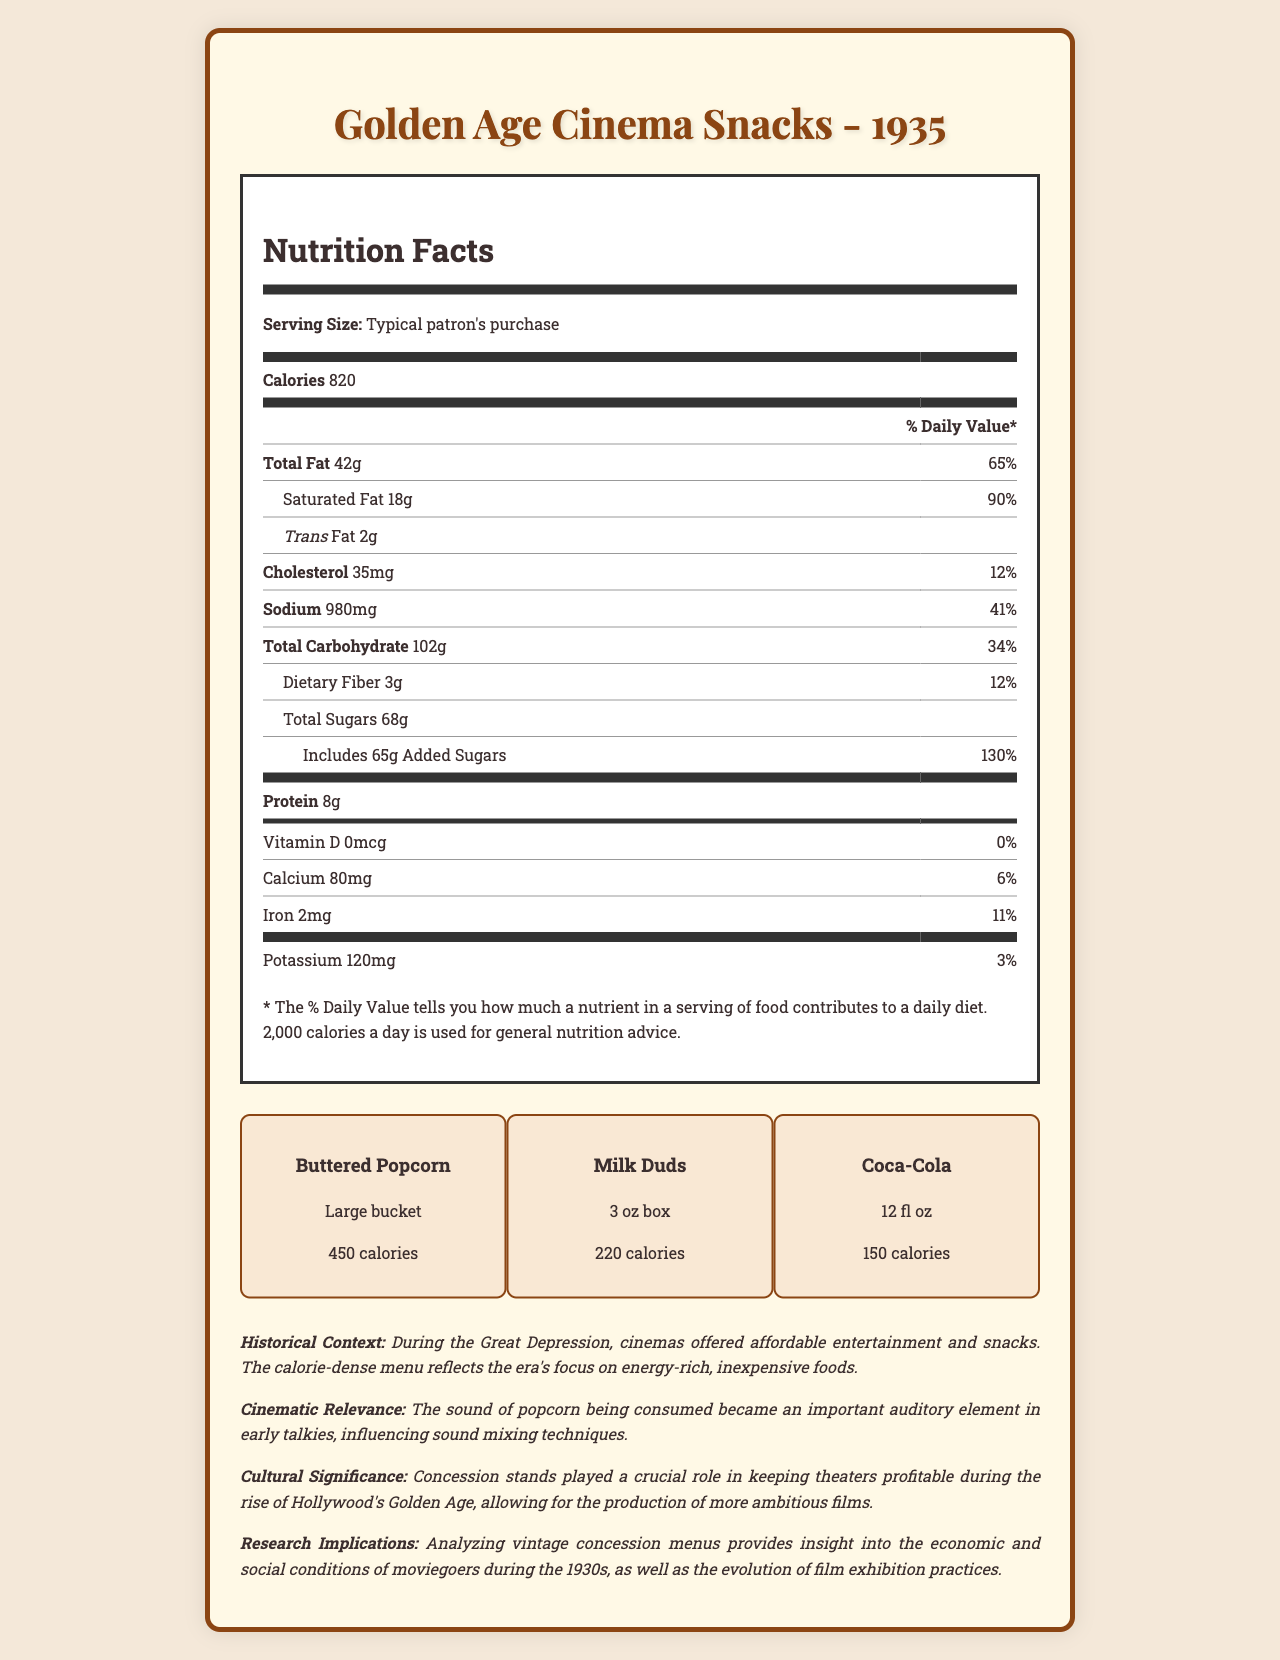what is the total calorie count for a typical patron's purchase? The document mentions that the calories per serving for a typical patron's purchase is 820.
Answer: 820 how many grams of total fat are present in the menu item? The document specifies that there are 42 grams of total fat in the serving size of a typical patron's purchase.
Answer: 42 grams what is the historical context mentioned in the document? The historical context is described in the document's context section.
Answer: During the Great Depression, cinemas offered affordable entertainment and snacks. The calorie-dense menu reflects the era's focus on energy-rich, inexpensive foods. which of the following menu items contains the highest number of calories? A. Buttered Popcorn B. Milk Duds C. Coca-Cola Buttered Popcorn has 450 calories, which is higher than Milk Duds (220 calories) and Coca-Cola (150 calories).
Answer: Buttered Popcorn what is the percentage of daily value for sodium in a typical patron's purchase? The sodium content is 980 mg, and this is 41% of the daily value for sodium.
Answer: 41% which item contributed the highest number of calories to the menu? Buttered Popcorn contributes the highest number of calories at 450.
Answer: Buttered Popcorn how many grams of added sugars are included in the purchase? The document indicates that there are 65 grams of added sugars in the typical patron's purchase.
Answer: 65 grams what is the cinematic relevance of the menu described in the document? The document's context section mentions this cinematic relevance.
Answer: The sound of popcorn being consumed became an important auditory element in early talkies, influencing sound mixing techniques. does the document mention the presence of any vitamins? The document mentions Vitamin D with a value of 0 mcg.
Answer: Yes summarize the document about Golden Age Cinema Snacks' menu from 1935. The summary captures the main points including nutritional details, menu items, historical and cultural context, cinematic relevance, and research implications.
Answer: The Golden Age Cinema Snacks menu from 1935 includes a nutrition facts label detailing the calorie and nutritional breakdown for a typical patron's purchase, which totals 820 calories. The menu items include Buttered Popcorn, Milk Duds, and Coca-Cola. The historical context indicates that during the Great Depression, cinemas provided energy-rich, inexpensive foods. Cinematic relevance is noted in the sound of popcorn enhancing early movies, and cultural significance highlights the economic importance of concession stands in cinema profitability. The research implications suggest insights into 1930s moviegoer lifestyles and the evolution of film exhibition. what is the total carbohydrate content of a typical patron's purchase? The document lists total carbohydrates as 102 grams in the nutrition facts section.
Answer: 102 grams what is the daily value percentage for saturated fat? A. 25% B. 75% C. 90% The document states that a typical purchase contains 18 grams of saturated fat, which equates to 90% of the daily value.
Answer: 90% what is the size of the Milk Duds item on the menu? The document specifies that the Milk Duds item is a 3 oz box.
Answer: 3 oz box how much protein is in a typical patron's purchase? The nutrition facts state that there are 8 grams of protein in a typical patron's purchase.
Answer: 8 grams is there any iron present in the typical purchase? The document shows that there are 2 mg of iron, which is 11% of the daily value.
Answer: Yes how did the calorie-dense menu items reflect the economic conditions of the 1930s? This information can be found in the historical context section.
Answer: The calorie-dense menu reflects the era's focus on energy-rich, inexpensive foods due to the Great Depression. what role did concession stands play during Hollywood's Golden Age? The cultural significance section of the document provides this information.
Answer: Concession stands played a crucial role in keeping theaters profitable during the rise of Hollywood's Golden Age, allowing for the production of more ambitious films. what's the total added sugar percentage of the daily value in the purchase? The document states that 65 grams of added sugars equals 130% of the daily value.
Answer: 130% what is the sodium content of Buttered Popcorn? The document provides the sodium content for a typical purchase but does not break it down by individual menu items.
Answer: Not enough information 